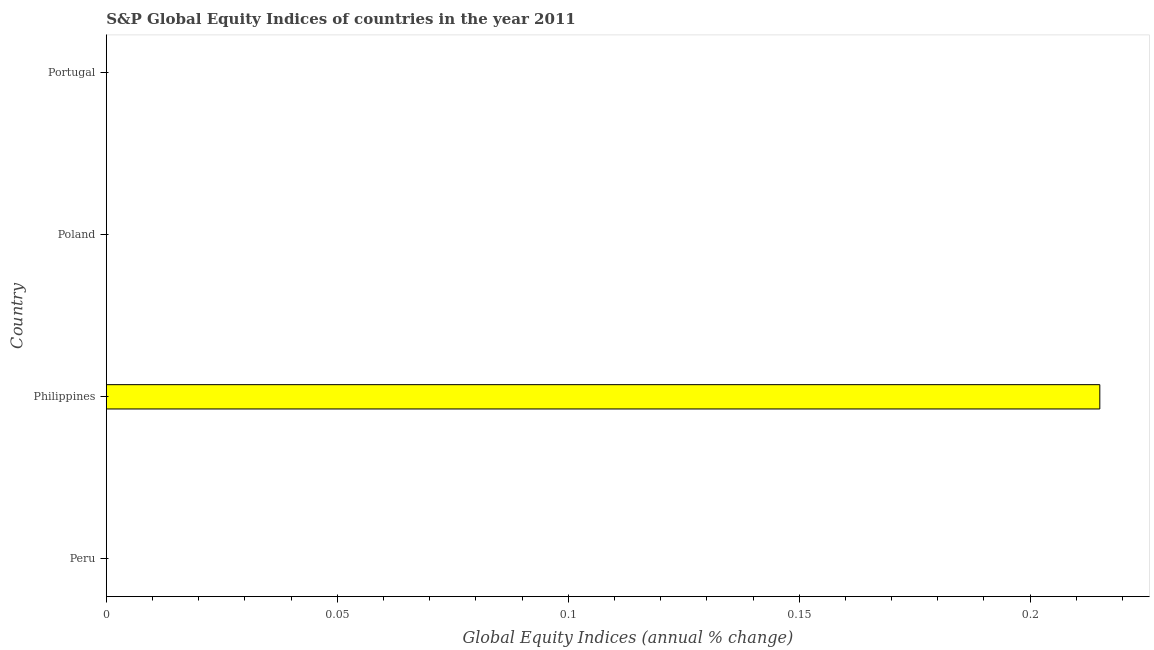Does the graph contain grids?
Your answer should be compact. No. What is the title of the graph?
Give a very brief answer. S&P Global Equity Indices of countries in the year 2011. What is the label or title of the X-axis?
Your response must be concise. Global Equity Indices (annual % change). What is the s&p global equity indices in Poland?
Make the answer very short. 0. Across all countries, what is the maximum s&p global equity indices?
Ensure brevity in your answer.  0.22. What is the sum of the s&p global equity indices?
Provide a succinct answer. 0.22. What is the average s&p global equity indices per country?
Offer a terse response. 0.05. What is the median s&p global equity indices?
Make the answer very short. 0. What is the difference between the highest and the lowest s&p global equity indices?
Keep it short and to the point. 0.22. In how many countries, is the s&p global equity indices greater than the average s&p global equity indices taken over all countries?
Give a very brief answer. 1. How many countries are there in the graph?
Keep it short and to the point. 4. Are the values on the major ticks of X-axis written in scientific E-notation?
Provide a succinct answer. No. What is the Global Equity Indices (annual % change) of Peru?
Keep it short and to the point. 0. What is the Global Equity Indices (annual % change) in Philippines?
Your response must be concise. 0.22. What is the Global Equity Indices (annual % change) in Portugal?
Your answer should be compact. 0. 